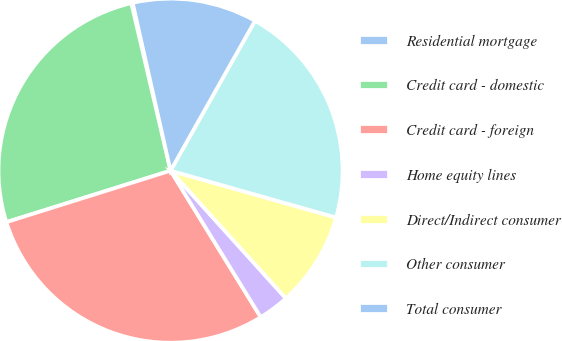Convert chart to OTSL. <chart><loc_0><loc_0><loc_500><loc_500><pie_chart><fcel>Residential mortgage<fcel>Credit card - domestic<fcel>Credit card - foreign<fcel>Home equity lines<fcel>Direct/Indirect consumer<fcel>Other consumer<fcel>Total consumer<nl><fcel>0.13%<fcel>26.17%<fcel>28.95%<fcel>2.91%<fcel>8.92%<fcel>21.22%<fcel>11.7%<nl></chart> 